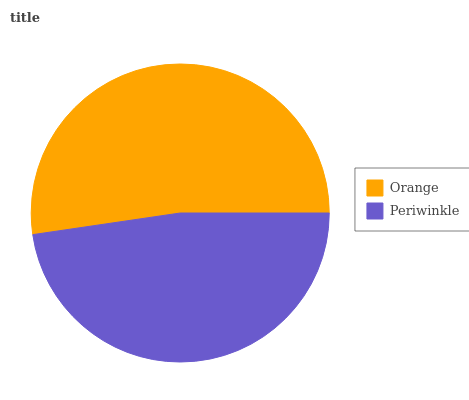Is Periwinkle the minimum?
Answer yes or no. Yes. Is Orange the maximum?
Answer yes or no. Yes. Is Periwinkle the maximum?
Answer yes or no. No. Is Orange greater than Periwinkle?
Answer yes or no. Yes. Is Periwinkle less than Orange?
Answer yes or no. Yes. Is Periwinkle greater than Orange?
Answer yes or no. No. Is Orange less than Periwinkle?
Answer yes or no. No. Is Orange the high median?
Answer yes or no. Yes. Is Periwinkle the low median?
Answer yes or no. Yes. Is Periwinkle the high median?
Answer yes or no. No. Is Orange the low median?
Answer yes or no. No. 